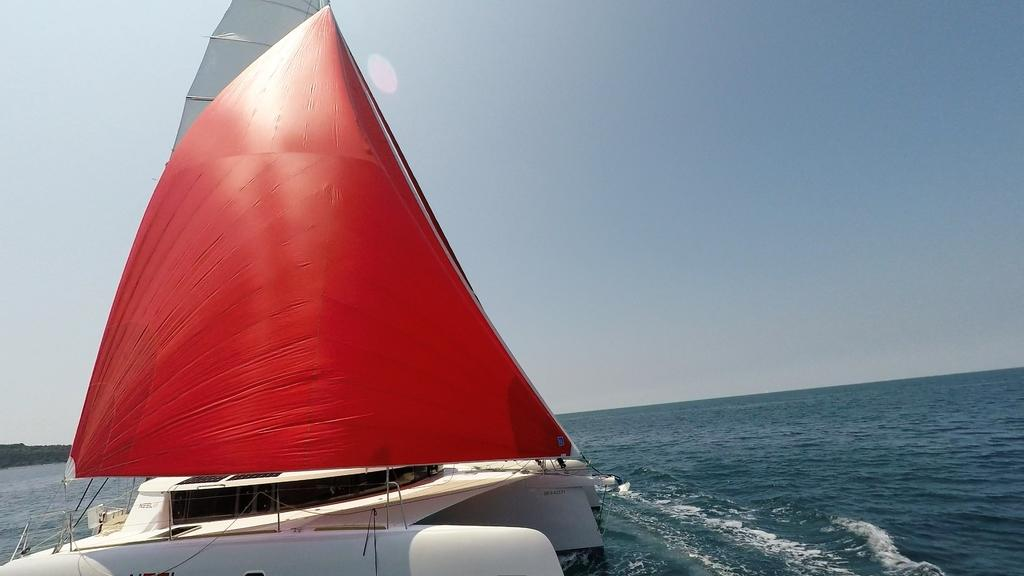What is sailing on the water in the image? There is a dinghy sailing on the water in the image. What can be seen on the left side of the image? There are trees on the left side of the image. How would you describe the sky in the image? The sky is clear in the image. What type of taste can be experienced from the trees in the image? Trees do not have a taste, so this cannot be experienced from the image. 